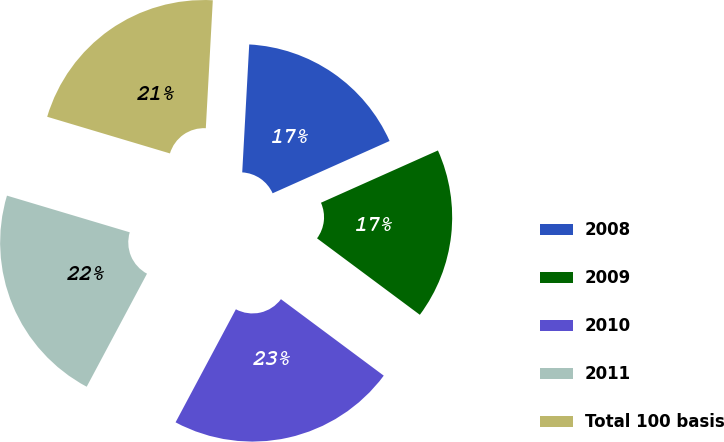Convert chart to OTSL. <chart><loc_0><loc_0><loc_500><loc_500><pie_chart><fcel>2008<fcel>2009<fcel>2010<fcel>2011<fcel>Total 100 basis<nl><fcel>17.44%<fcel>16.87%<fcel>22.62%<fcel>21.82%<fcel>21.25%<nl></chart> 